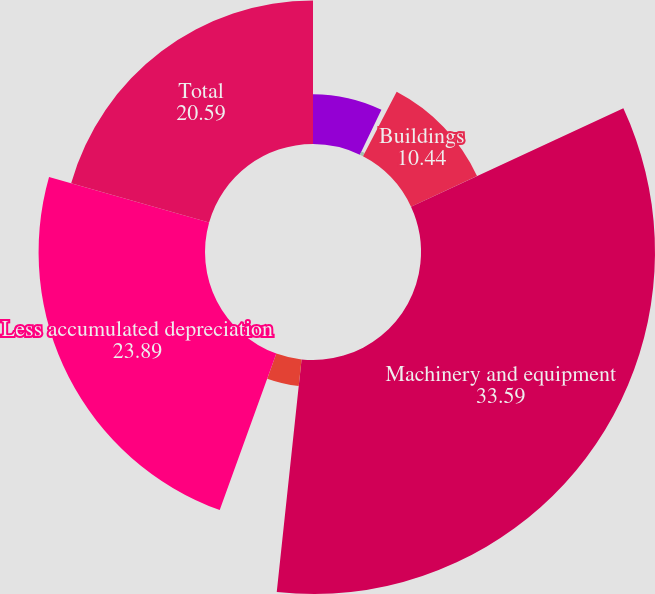<chart> <loc_0><loc_0><loc_500><loc_500><pie_chart><fcel>Summary of Property Plant and<fcel>Land<fcel>Buildings<fcel>Machinery and equipment<fcel>Construction in progress<fcel>Less accumulated depreciation<fcel>Total<nl><fcel>7.14%<fcel>0.52%<fcel>10.44%<fcel>33.59%<fcel>3.83%<fcel>23.89%<fcel>20.59%<nl></chart> 